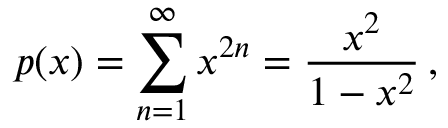<formula> <loc_0><loc_0><loc_500><loc_500>p ( x ) = \sum _ { n = 1 } ^ { \infty } x ^ { 2 n } = { \frac { x ^ { 2 } } { 1 - x ^ { 2 } } } \, ,</formula> 